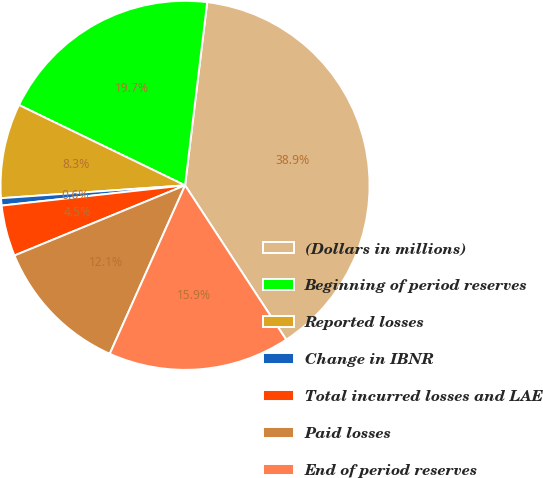<chart> <loc_0><loc_0><loc_500><loc_500><pie_chart><fcel>(Dollars in millions)<fcel>Beginning of period reserves<fcel>Reported losses<fcel>Change in IBNR<fcel>Total incurred losses and LAE<fcel>Paid losses<fcel>End of period reserves<nl><fcel>38.85%<fcel>19.74%<fcel>8.28%<fcel>0.64%<fcel>4.46%<fcel>12.1%<fcel>15.92%<nl></chart> 